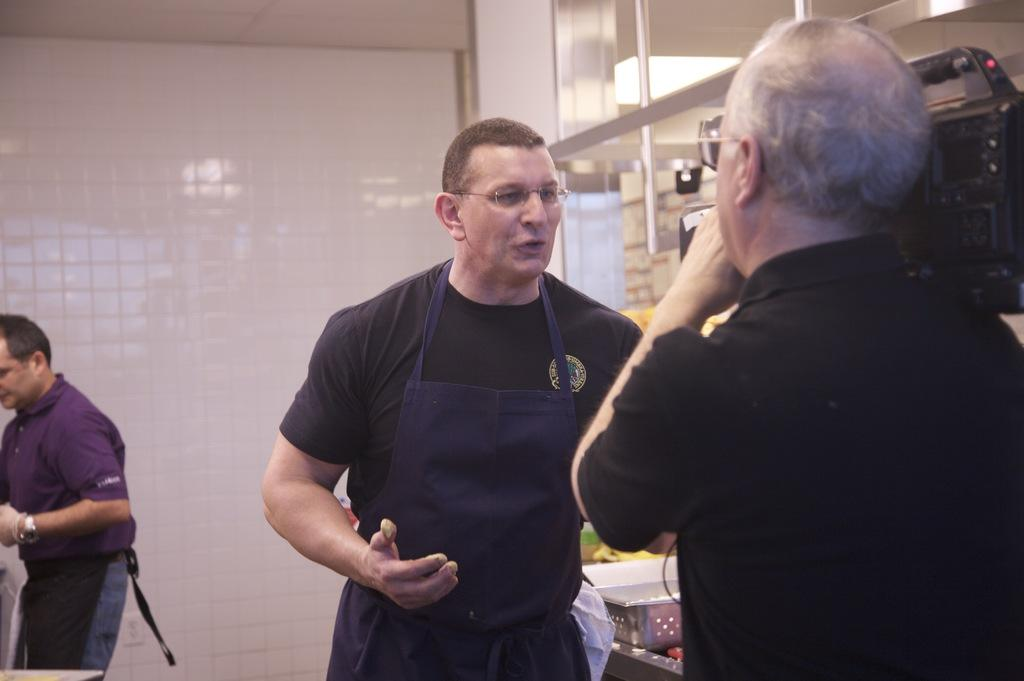What is happening in the image? There are people standing in the image. Can you describe any specific actions or objects being held by the people? One person is holding a camera. How many cats can be seen playing with plants in the image? There are no cats or plants present in the image; it only features people standing and one person holding a camera. 